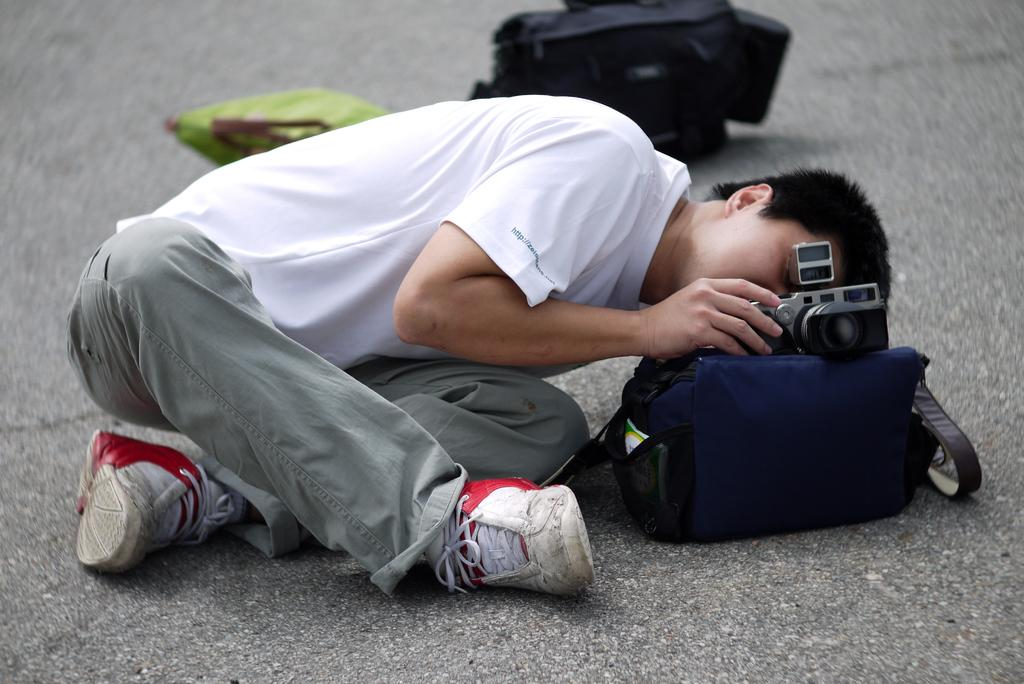Where is the image taken? The image is taken on a road. What is the guy in the image doing? The guy is holding a camera. How is the camera positioned in the image? The camera is placed on top of a blue bag. What can be seen in the background of the image? There is a black bag in the background. How many children are playing with the coil in the image? There are no children or coils present in the image. 